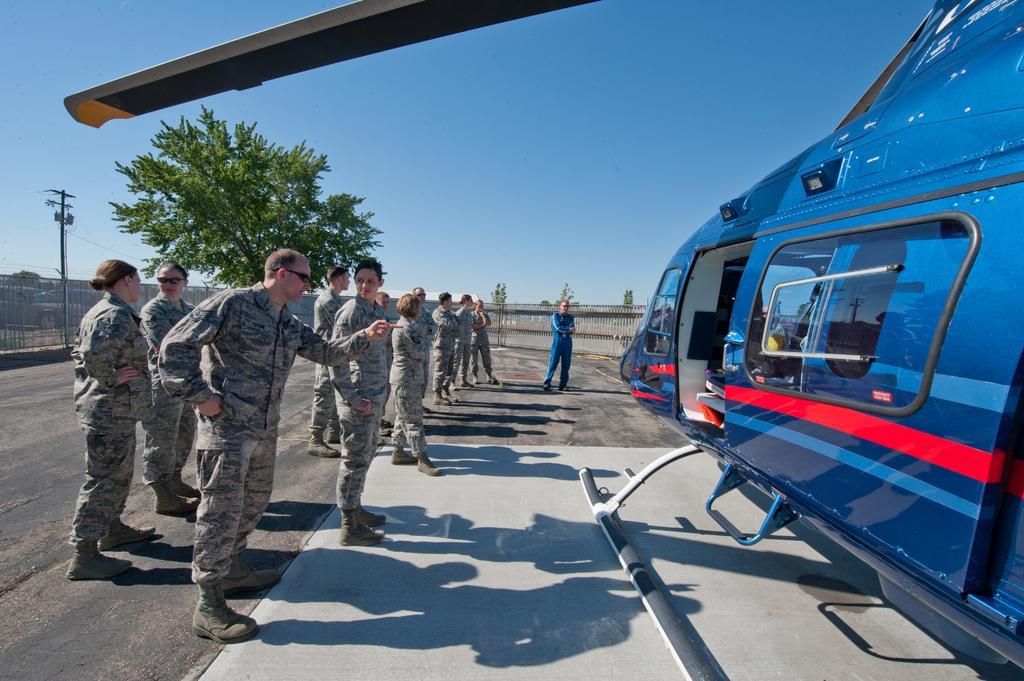How would you summarize this image in a sentence or two? This is an outside view. On the right side there is a helicopter on the ground. On the left side few people are standing facing towards the right side. In the background there is a fencing and trees. On the left side there is a pole. At the top of the image I can see the sky in blue color. 